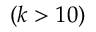<formula> <loc_0><loc_0><loc_500><loc_500>( k > 1 0 )</formula> 